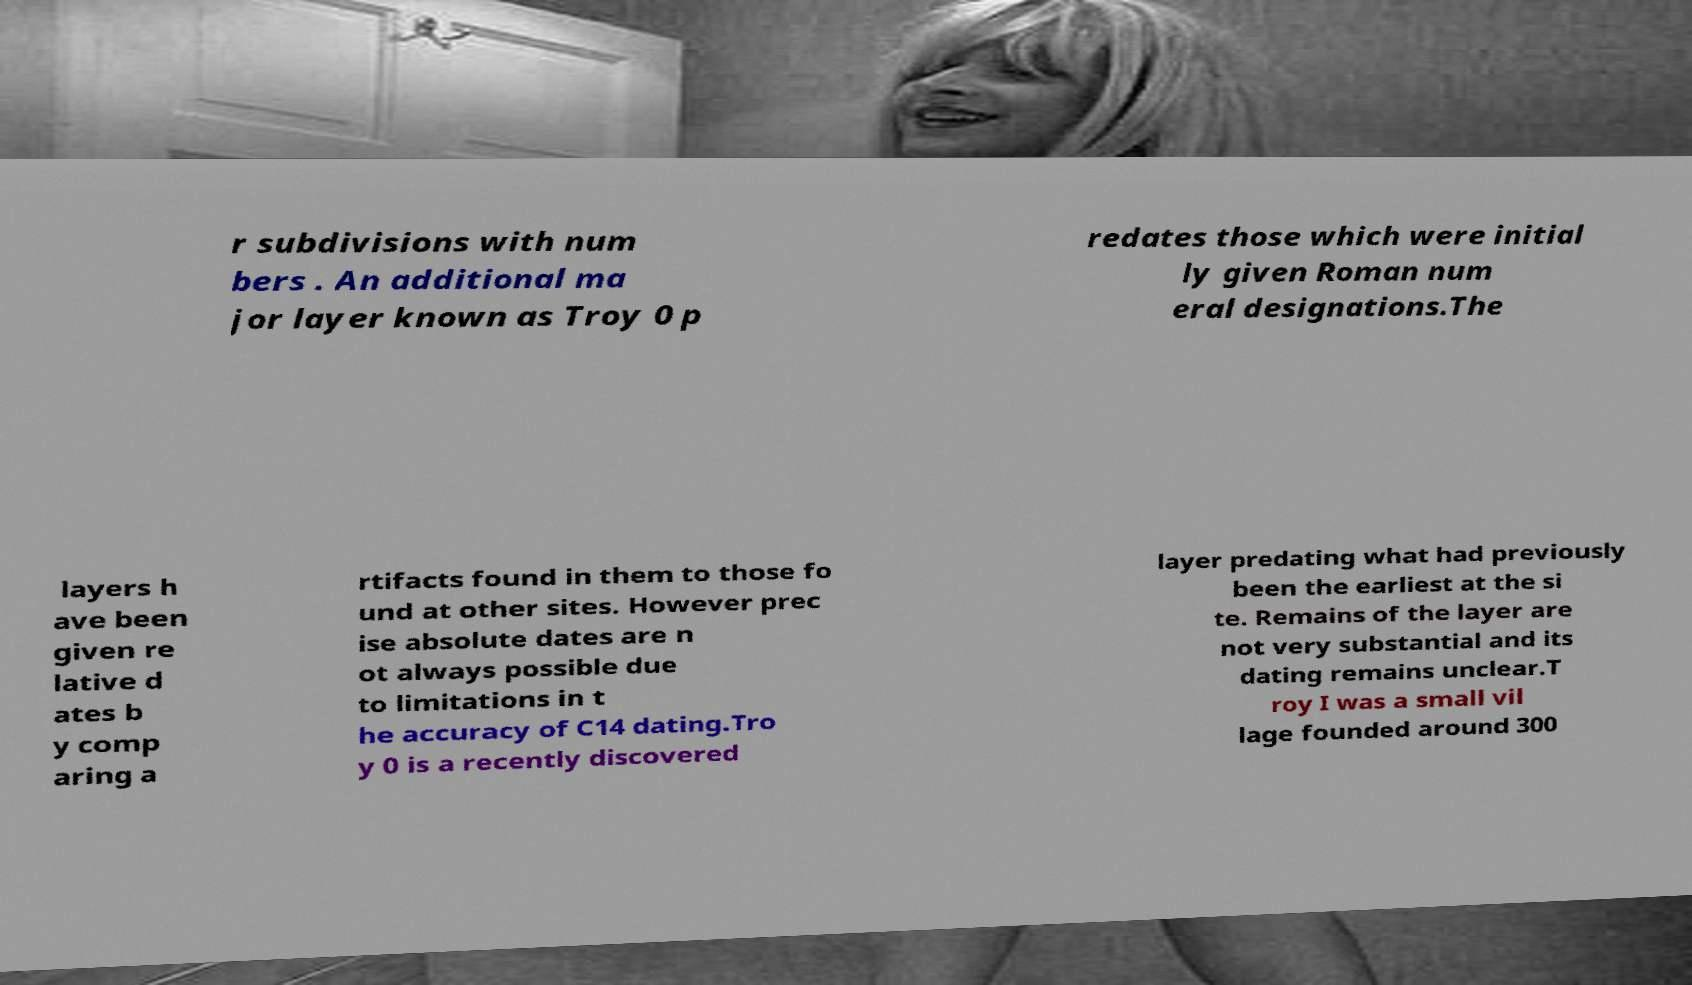There's text embedded in this image that I need extracted. Can you transcribe it verbatim? r subdivisions with num bers . An additional ma jor layer known as Troy 0 p redates those which were initial ly given Roman num eral designations.The layers h ave been given re lative d ates b y comp aring a rtifacts found in them to those fo und at other sites. However prec ise absolute dates are n ot always possible due to limitations in t he accuracy of C14 dating.Tro y 0 is a recently discovered layer predating what had previously been the earliest at the si te. Remains of the layer are not very substantial and its dating remains unclear.T roy I was a small vil lage founded around 300 